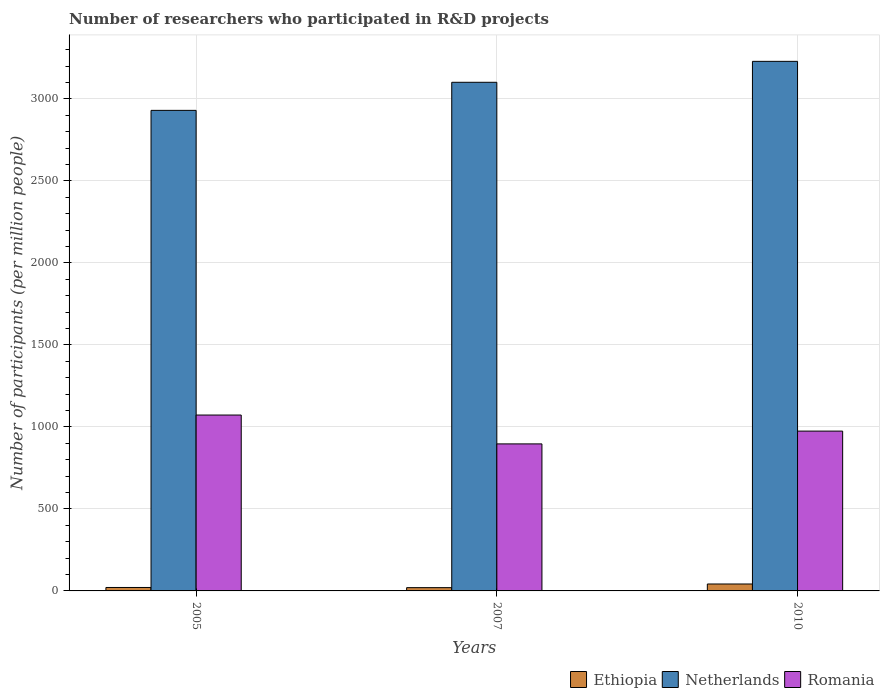How many groups of bars are there?
Your response must be concise. 3. What is the number of researchers who participated in R&D projects in Romania in 2007?
Provide a short and direct response. 896.49. Across all years, what is the maximum number of researchers who participated in R&D projects in Romania?
Your answer should be compact. 1072.42. Across all years, what is the minimum number of researchers who participated in R&D projects in Romania?
Provide a succinct answer. 896.49. In which year was the number of researchers who participated in R&D projects in Ethiopia maximum?
Offer a very short reply. 2010. What is the total number of researchers who participated in R&D projects in Netherlands in the graph?
Provide a succinct answer. 9260.43. What is the difference between the number of researchers who participated in R&D projects in Romania in 2007 and that in 2010?
Offer a terse response. -77.95. What is the difference between the number of researchers who participated in R&D projects in Romania in 2007 and the number of researchers who participated in R&D projects in Netherlands in 2010?
Ensure brevity in your answer.  -2332.49. What is the average number of researchers who participated in R&D projects in Ethiopia per year?
Keep it short and to the point. 27.74. In the year 2007, what is the difference between the number of researchers who participated in R&D projects in Ethiopia and number of researchers who participated in R&D projects in Romania?
Your answer should be very brief. -876.52. In how many years, is the number of researchers who participated in R&D projects in Netherlands greater than 800?
Offer a terse response. 3. What is the ratio of the number of researchers who participated in R&D projects in Romania in 2007 to that in 2010?
Your response must be concise. 0.92. Is the difference between the number of researchers who participated in R&D projects in Ethiopia in 2005 and 2010 greater than the difference between the number of researchers who participated in R&D projects in Romania in 2005 and 2010?
Your answer should be very brief. No. What is the difference between the highest and the second highest number of researchers who participated in R&D projects in Netherlands?
Provide a short and direct response. 127.67. What is the difference between the highest and the lowest number of researchers who participated in R&D projects in Romania?
Offer a terse response. 175.94. What does the 2nd bar from the left in 2005 represents?
Keep it short and to the point. Netherlands. What does the 1st bar from the right in 2007 represents?
Give a very brief answer. Romania. Are all the bars in the graph horizontal?
Make the answer very short. No. How many years are there in the graph?
Provide a succinct answer. 3. What is the difference between two consecutive major ticks on the Y-axis?
Give a very brief answer. 500. Are the values on the major ticks of Y-axis written in scientific E-notation?
Ensure brevity in your answer.  No. Where does the legend appear in the graph?
Make the answer very short. Bottom right. How many legend labels are there?
Provide a succinct answer. 3. How are the legend labels stacked?
Your answer should be very brief. Horizontal. What is the title of the graph?
Ensure brevity in your answer.  Number of researchers who participated in R&D projects. What is the label or title of the Y-axis?
Provide a succinct answer. Number of participants (per million people). What is the Number of participants (per million people) of Ethiopia in 2005?
Provide a succinct answer. 20.99. What is the Number of participants (per million people) of Netherlands in 2005?
Ensure brevity in your answer.  2930.14. What is the Number of participants (per million people) in Romania in 2005?
Make the answer very short. 1072.42. What is the Number of participants (per million people) in Ethiopia in 2007?
Your answer should be compact. 19.96. What is the Number of participants (per million people) in Netherlands in 2007?
Give a very brief answer. 3101.31. What is the Number of participants (per million people) in Romania in 2007?
Provide a succinct answer. 896.49. What is the Number of participants (per million people) of Ethiopia in 2010?
Offer a very short reply. 42.27. What is the Number of participants (per million people) in Netherlands in 2010?
Provide a short and direct response. 3228.98. What is the Number of participants (per million people) of Romania in 2010?
Provide a succinct answer. 974.44. Across all years, what is the maximum Number of participants (per million people) in Ethiopia?
Make the answer very short. 42.27. Across all years, what is the maximum Number of participants (per million people) in Netherlands?
Your response must be concise. 3228.98. Across all years, what is the maximum Number of participants (per million people) in Romania?
Offer a terse response. 1072.42. Across all years, what is the minimum Number of participants (per million people) of Ethiopia?
Your answer should be compact. 19.96. Across all years, what is the minimum Number of participants (per million people) in Netherlands?
Provide a succinct answer. 2930.14. Across all years, what is the minimum Number of participants (per million people) in Romania?
Ensure brevity in your answer.  896.49. What is the total Number of participants (per million people) in Ethiopia in the graph?
Offer a terse response. 83.22. What is the total Number of participants (per million people) in Netherlands in the graph?
Offer a terse response. 9260.43. What is the total Number of participants (per million people) of Romania in the graph?
Provide a succinct answer. 2943.35. What is the difference between the Number of participants (per million people) in Ethiopia in 2005 and that in 2007?
Keep it short and to the point. 1.02. What is the difference between the Number of participants (per million people) of Netherlands in 2005 and that in 2007?
Offer a very short reply. -171.17. What is the difference between the Number of participants (per million people) in Romania in 2005 and that in 2007?
Your response must be concise. 175.94. What is the difference between the Number of participants (per million people) in Ethiopia in 2005 and that in 2010?
Give a very brief answer. -21.28. What is the difference between the Number of participants (per million people) of Netherlands in 2005 and that in 2010?
Provide a succinct answer. -298.84. What is the difference between the Number of participants (per million people) of Romania in 2005 and that in 2010?
Your response must be concise. 97.98. What is the difference between the Number of participants (per million people) of Ethiopia in 2007 and that in 2010?
Provide a short and direct response. -22.3. What is the difference between the Number of participants (per million people) in Netherlands in 2007 and that in 2010?
Your answer should be very brief. -127.67. What is the difference between the Number of participants (per million people) of Romania in 2007 and that in 2010?
Make the answer very short. -77.95. What is the difference between the Number of participants (per million people) in Ethiopia in 2005 and the Number of participants (per million people) in Netherlands in 2007?
Provide a short and direct response. -3080.32. What is the difference between the Number of participants (per million people) of Ethiopia in 2005 and the Number of participants (per million people) of Romania in 2007?
Your response must be concise. -875.5. What is the difference between the Number of participants (per million people) of Netherlands in 2005 and the Number of participants (per million people) of Romania in 2007?
Offer a very short reply. 2033.65. What is the difference between the Number of participants (per million people) of Ethiopia in 2005 and the Number of participants (per million people) of Netherlands in 2010?
Your response must be concise. -3207.99. What is the difference between the Number of participants (per million people) in Ethiopia in 2005 and the Number of participants (per million people) in Romania in 2010?
Keep it short and to the point. -953.45. What is the difference between the Number of participants (per million people) of Netherlands in 2005 and the Number of participants (per million people) of Romania in 2010?
Give a very brief answer. 1955.7. What is the difference between the Number of participants (per million people) of Ethiopia in 2007 and the Number of participants (per million people) of Netherlands in 2010?
Your response must be concise. -3209.01. What is the difference between the Number of participants (per million people) in Ethiopia in 2007 and the Number of participants (per million people) in Romania in 2010?
Offer a very short reply. -954.48. What is the difference between the Number of participants (per million people) of Netherlands in 2007 and the Number of participants (per million people) of Romania in 2010?
Offer a terse response. 2126.87. What is the average Number of participants (per million people) of Ethiopia per year?
Offer a very short reply. 27.74. What is the average Number of participants (per million people) in Netherlands per year?
Your response must be concise. 3086.81. What is the average Number of participants (per million people) in Romania per year?
Provide a succinct answer. 981.12. In the year 2005, what is the difference between the Number of participants (per million people) of Ethiopia and Number of participants (per million people) of Netherlands?
Your answer should be very brief. -2909.15. In the year 2005, what is the difference between the Number of participants (per million people) in Ethiopia and Number of participants (per million people) in Romania?
Offer a terse response. -1051.43. In the year 2005, what is the difference between the Number of participants (per million people) in Netherlands and Number of participants (per million people) in Romania?
Provide a short and direct response. 1857.72. In the year 2007, what is the difference between the Number of participants (per million people) of Ethiopia and Number of participants (per million people) of Netherlands?
Your answer should be compact. -3081.35. In the year 2007, what is the difference between the Number of participants (per million people) of Ethiopia and Number of participants (per million people) of Romania?
Make the answer very short. -876.52. In the year 2007, what is the difference between the Number of participants (per million people) in Netherlands and Number of participants (per million people) in Romania?
Your answer should be very brief. 2204.83. In the year 2010, what is the difference between the Number of participants (per million people) in Ethiopia and Number of participants (per million people) in Netherlands?
Offer a very short reply. -3186.71. In the year 2010, what is the difference between the Number of participants (per million people) in Ethiopia and Number of participants (per million people) in Romania?
Offer a terse response. -932.17. In the year 2010, what is the difference between the Number of participants (per million people) of Netherlands and Number of participants (per million people) of Romania?
Your response must be concise. 2254.54. What is the ratio of the Number of participants (per million people) in Ethiopia in 2005 to that in 2007?
Your response must be concise. 1.05. What is the ratio of the Number of participants (per million people) of Netherlands in 2005 to that in 2007?
Give a very brief answer. 0.94. What is the ratio of the Number of participants (per million people) in Romania in 2005 to that in 2007?
Give a very brief answer. 1.2. What is the ratio of the Number of participants (per million people) in Ethiopia in 2005 to that in 2010?
Your answer should be compact. 0.5. What is the ratio of the Number of participants (per million people) in Netherlands in 2005 to that in 2010?
Offer a terse response. 0.91. What is the ratio of the Number of participants (per million people) of Romania in 2005 to that in 2010?
Your response must be concise. 1.1. What is the ratio of the Number of participants (per million people) in Ethiopia in 2007 to that in 2010?
Give a very brief answer. 0.47. What is the ratio of the Number of participants (per million people) in Netherlands in 2007 to that in 2010?
Provide a succinct answer. 0.96. What is the difference between the highest and the second highest Number of participants (per million people) in Ethiopia?
Offer a very short reply. 21.28. What is the difference between the highest and the second highest Number of participants (per million people) of Netherlands?
Offer a very short reply. 127.67. What is the difference between the highest and the second highest Number of participants (per million people) of Romania?
Your answer should be very brief. 97.98. What is the difference between the highest and the lowest Number of participants (per million people) in Ethiopia?
Give a very brief answer. 22.3. What is the difference between the highest and the lowest Number of participants (per million people) in Netherlands?
Give a very brief answer. 298.84. What is the difference between the highest and the lowest Number of participants (per million people) of Romania?
Your answer should be very brief. 175.94. 